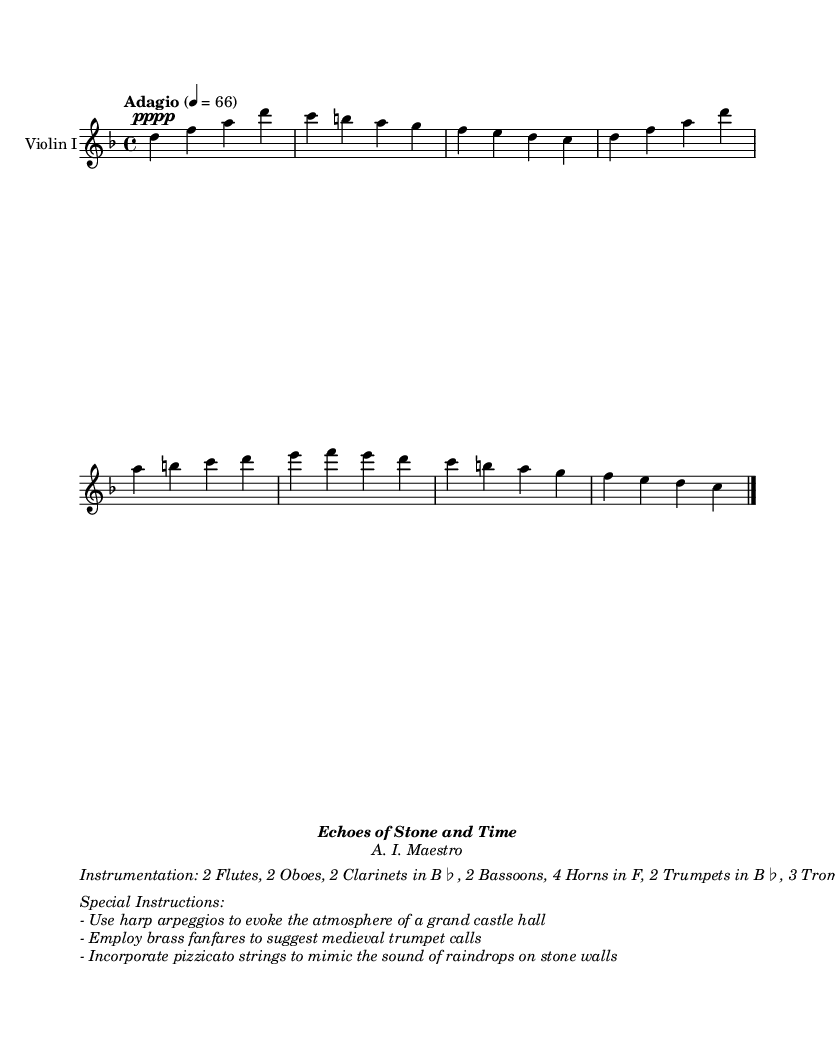What is the tempo of this piece? The tempo marking is "Adagio," which indicates a slow and leisurely pace. This can be identified at the beginning of the music, where the tempo directive is provided.
Answer: Adagio What is the key signature of this music? The key signature indicated is D minor, which has one flat (B♭). This is shown at the beginning of the score where the key signature is placed.
Answer: D minor What is the time signature of this music? The time signature specified is 4/4, which means there are four beats in each measure and the quarter note gets one beat. This is prominently displayed at the beginning of the score.
Answer: 4/4 How many violins are scored in this piece? There are 2 violins indicated in the instrumentation list within the score. This can be found in the text detailing the instrumentation below the staff.
Answer: 2 What is the main dynamic indication for the violin part? The dynamic marking for the violin part is "pppp," indicating the need for a very soft performance. This marking is placed at the start of the violin staff.
Answer: pppp What is one of the special instructions for the harp? One of the special instructions suggests using harp arpeggios to evoke the atmosphere of a grand castle hall. This is included in the list of special instructions formatted as italic text.
Answer: Use harp arpeggios What instrumental effect is suggested to mimic rain on stone? It is suggested to incorporate pizzicato strings to mimic the sound of raindrops on stone walls. This instruction is also detailed in the special instructions section.
Answer: Pizzicato strings 